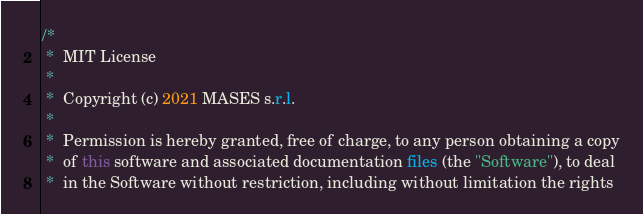<code> <loc_0><loc_0><loc_500><loc_500><_Java_>/*
 *  MIT License
 *
 *  Copyright (c) 2021 MASES s.r.l.
 *
 *  Permission is hereby granted, free of charge, to any person obtaining a copy
 *  of this software and associated documentation files (the "Software"), to deal
 *  in the Software without restriction, including without limitation the rights</code> 